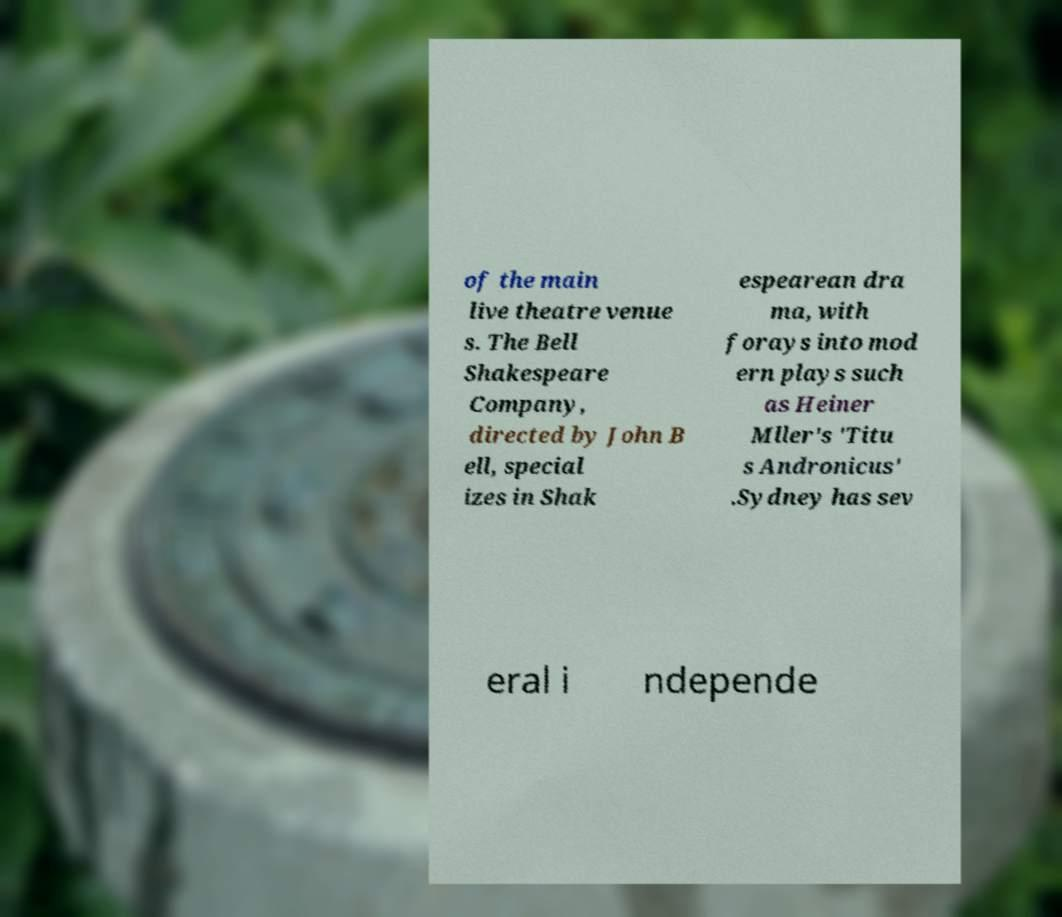Please identify and transcribe the text found in this image. of the main live theatre venue s. The Bell Shakespeare Company, directed by John B ell, special izes in Shak espearean dra ma, with forays into mod ern plays such as Heiner Mller's 'Titu s Andronicus' .Sydney has sev eral i ndepende 